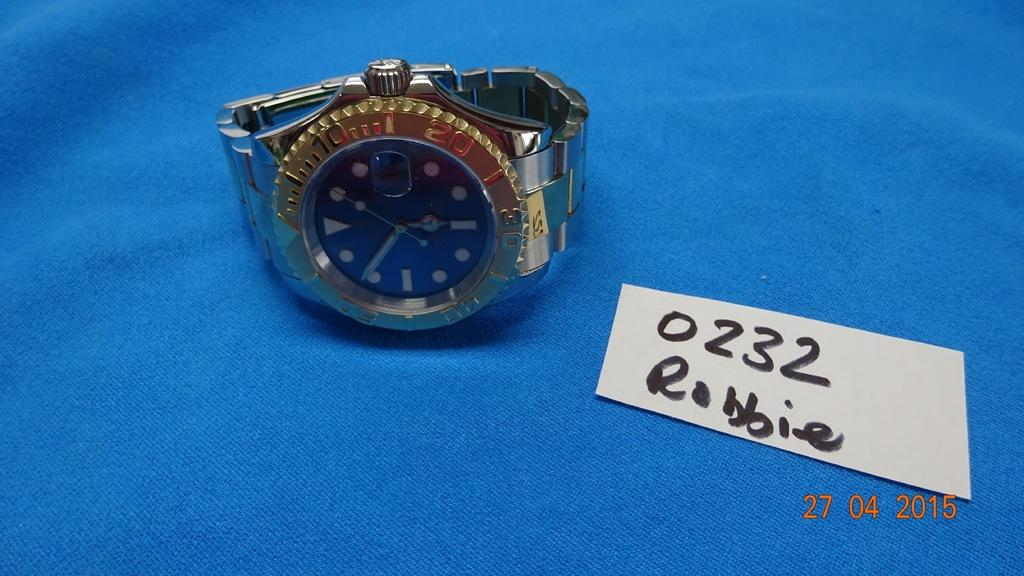<image>
Summarize the visual content of the image. A wristwatch sits next to a numbered card with the name Robbie on it. 